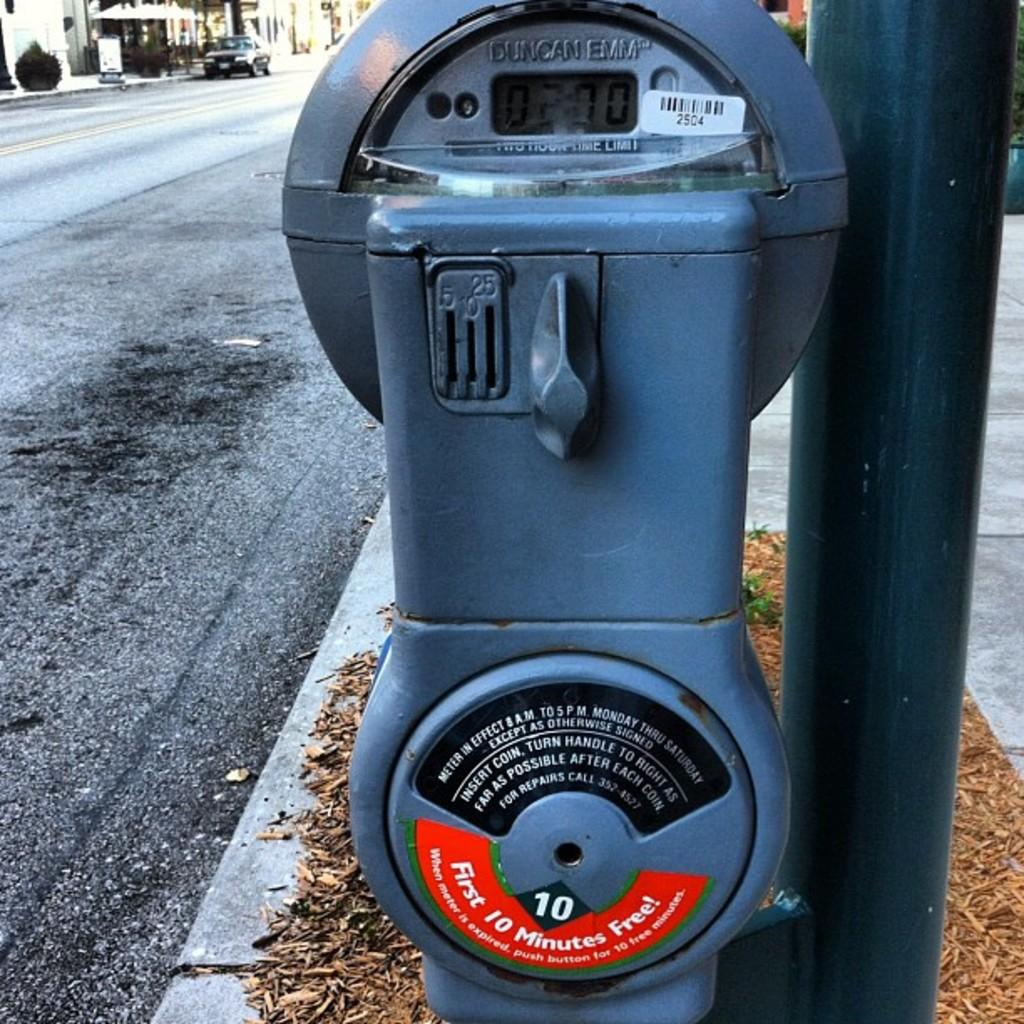<image>
Write a terse but informative summary of the picture. A Duncan Emm brand parking meter advertises that the first 10 minutes are free. 